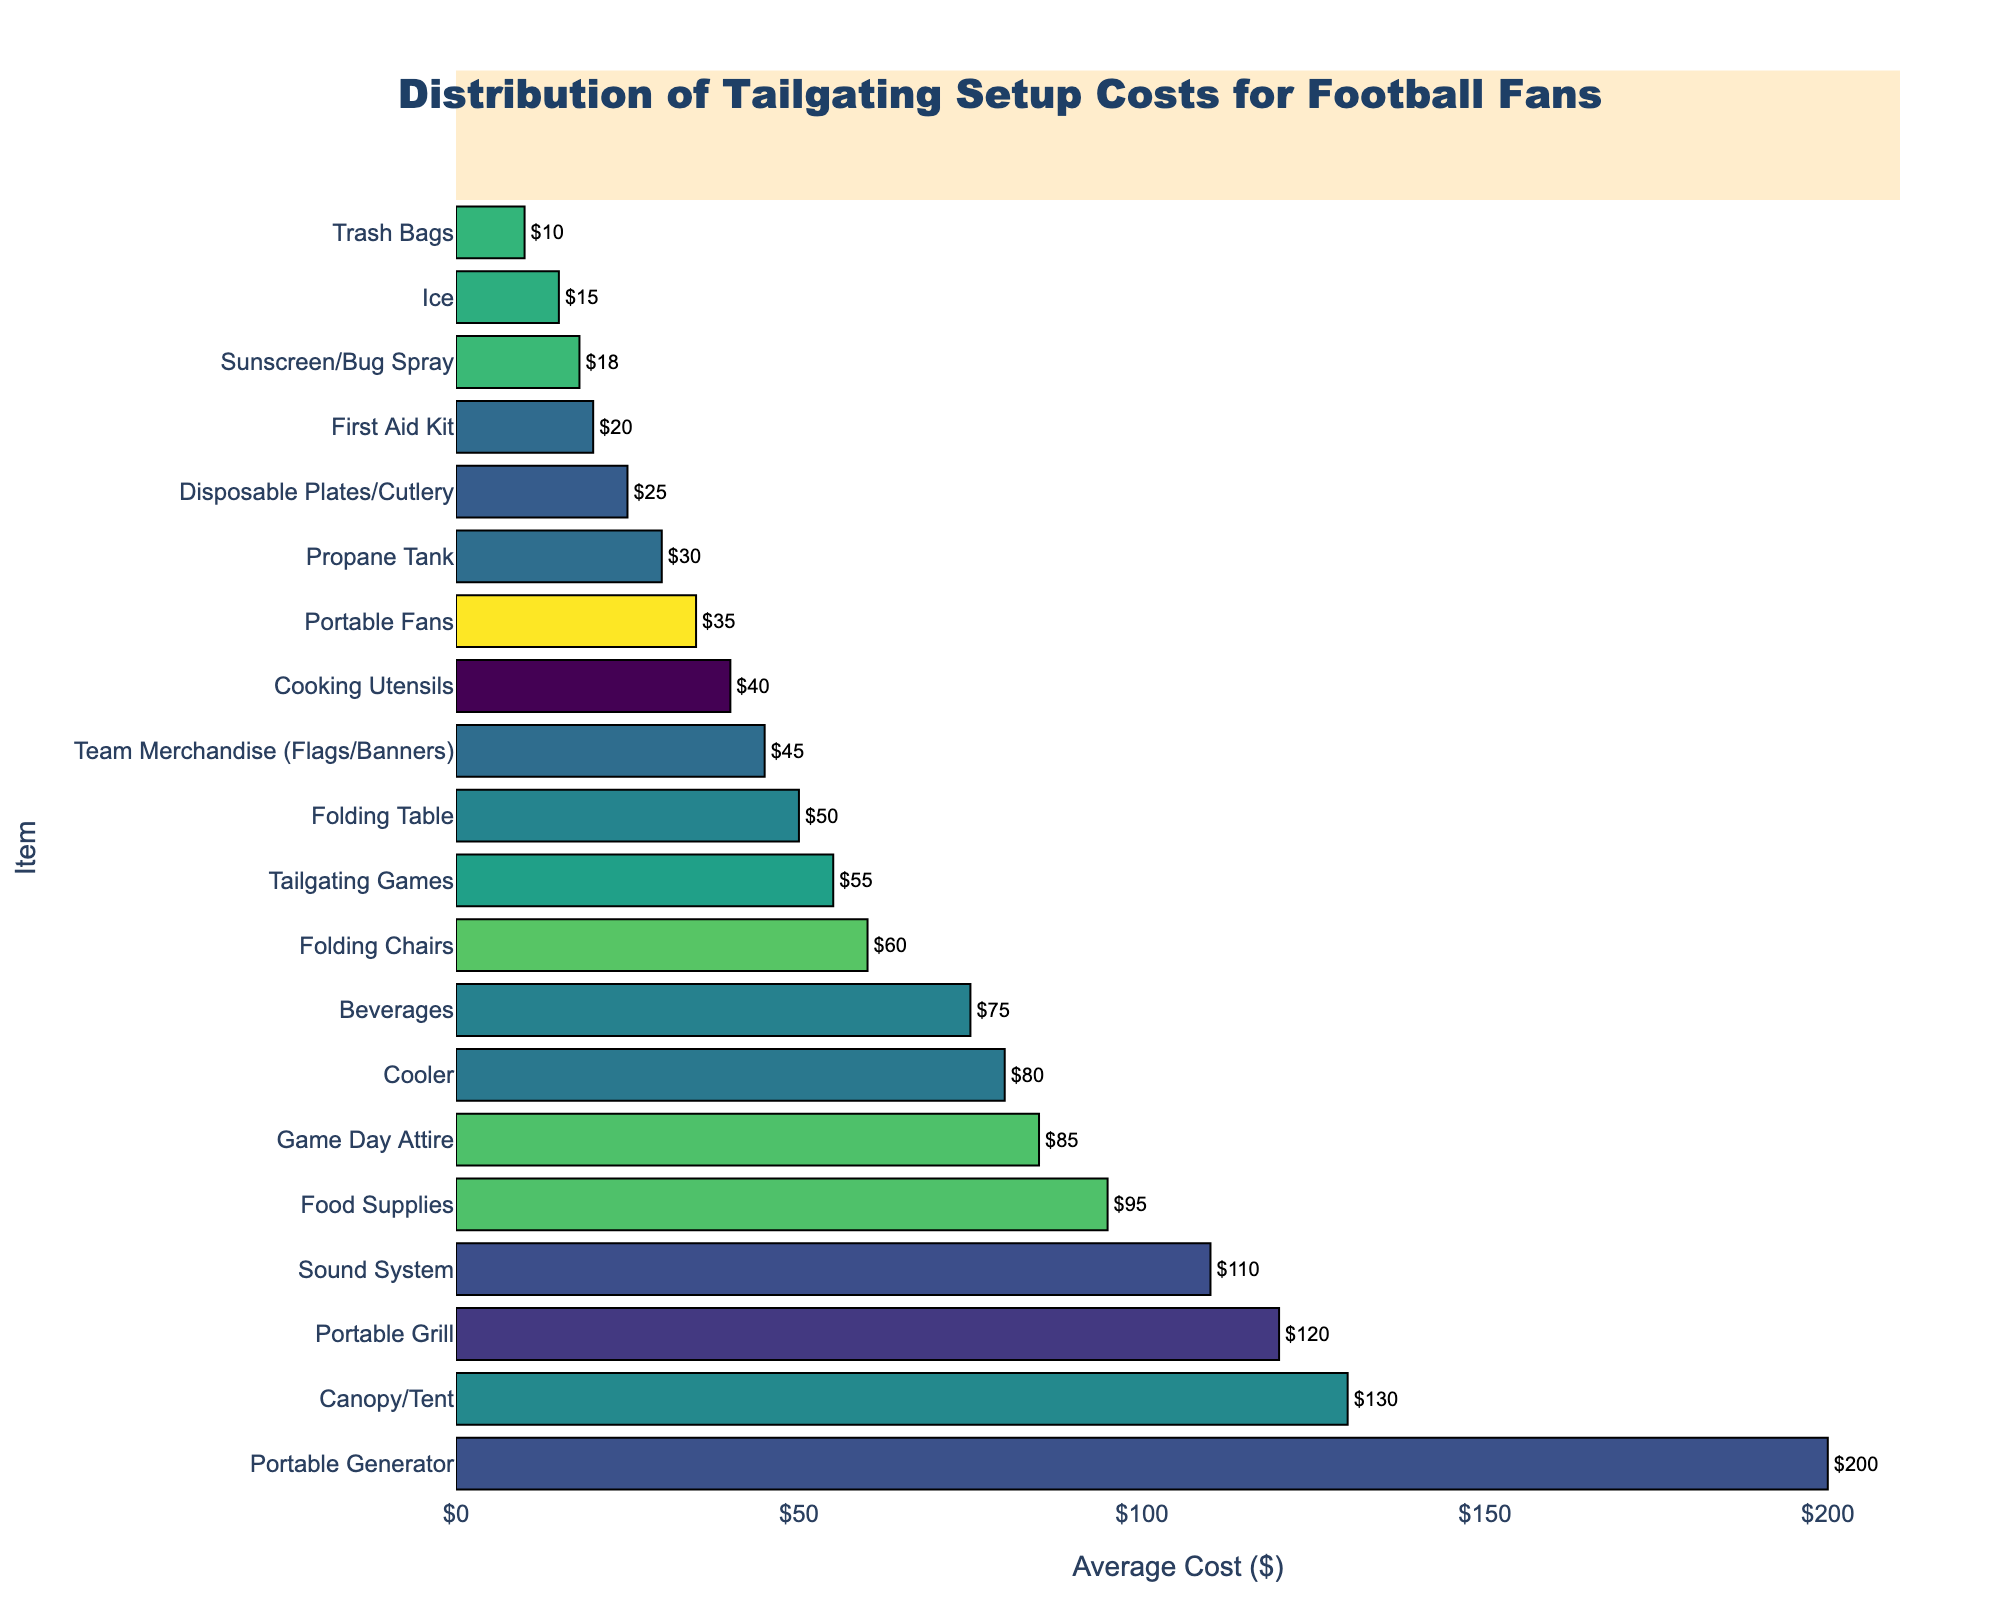Which item has the highest average cost? Look at the bar representing the highest value in the horizontal bar chart. The item with the longest bar corresponds to the highest average cost.
Answer: Portable Generator Which item has the lowest average cost? Identify the shortest bar on the left side of the horizontal bar chart. The item with the shortest bar is the one with the lowest average cost.
Answer: Trash Bags How much more does a Canopy/Tent cost compared to a Cooler? Find the values for both Canopy/Tent and Cooler from the chart and subtract the average cost of the Cooler from that of the Canopy/Tent. Canopy/Tent: $130, Cooler: $80. $130 - $80 = $50.
Answer: $50 What is the combined average cost of Food Supplies and Beverages? Locate the bars for Food Supplies and Beverages. Then add their average costs together. Food Supplies: $95, Beverages: $75. $95 + $75 = $170.
Answer: $170 If you have a budget of $200, which two items can you buy together without exceeding the budget? Identify combinations of two items from the chart whose costs add up to no more than $200. One possible pair is Food Supplies ($95) and Folding Table ($50), adding up to $145.
Answer: Various pairs, one example: Food Supplies and Folding Table List all the items that have an average cost higher than $100. Find the bars that are longer than the 100 mark on the x-axis. These items are: Portable Grill ($120), Canopy/Tent ($130), Portable Generator ($200), and Sound System ($110).
Answer: Portable Grill, Canopy/Tent, Portable Generator, Sound System By how much does the average cost of Game Day Attire differ from that of Tailgating Games? Subtract the average cost of Tailgating Games from the average cost of Game Day Attire. Game Day Attire: $85, Tailgating Games: $55. $85 - $55 = $30.
Answer: $30 Which items have an average cost between $20 and $40? Look at the bars whose lengths correspond to values between $20 and $40. The items are: Propane Tank ($30), First Aid Kit ($20), Sunscreen/Bug Spray ($18), and Portable Fans ($35).
Answer: Propane Tank, First Aid Kit, Sunscreen/Bug Spray, Portable Fans 